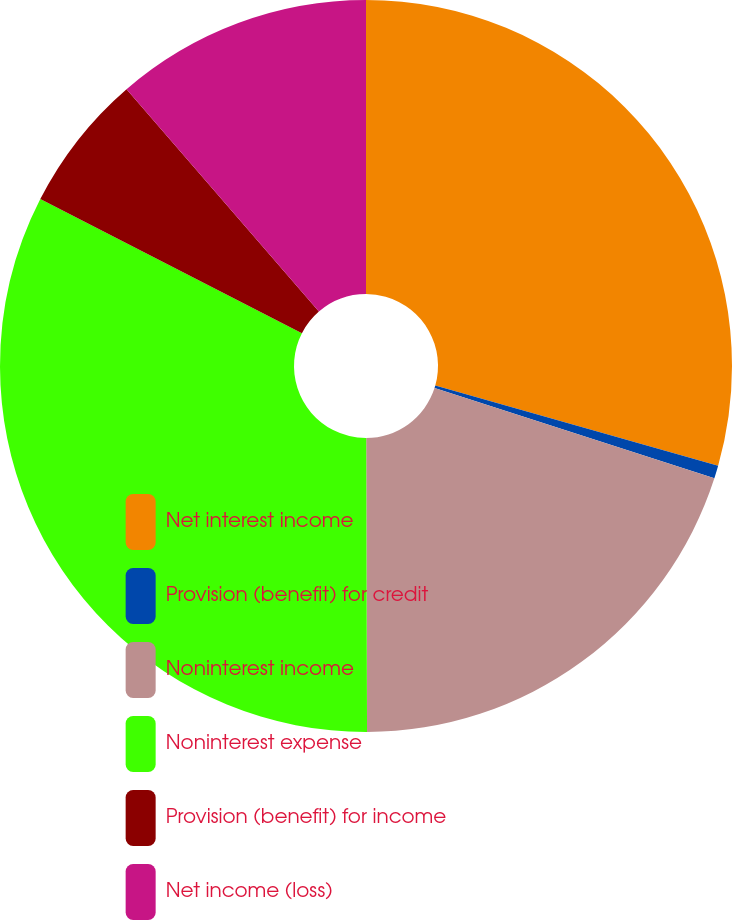Convert chart to OTSL. <chart><loc_0><loc_0><loc_500><loc_500><pie_chart><fcel>Net interest income<fcel>Provision (benefit) for credit<fcel>Noninterest income<fcel>Noninterest expense<fcel>Provision (benefit) for income<fcel>Net income (loss)<nl><fcel>29.39%<fcel>0.57%<fcel>19.99%<fcel>32.58%<fcel>6.11%<fcel>11.35%<nl></chart> 